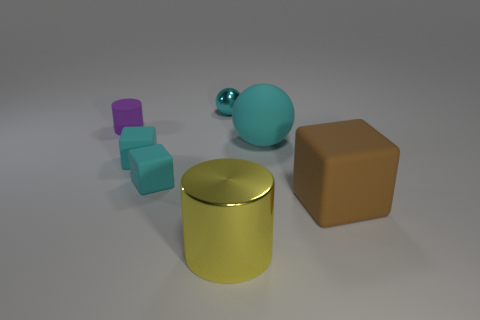There is a shiny object left of the yellow cylinder; what number of matte things are in front of it?
Make the answer very short. 5. Are the cylinder that is behind the brown matte block and the thing that is right of the big cyan rubber ball made of the same material?
Your answer should be compact. Yes. What number of large cyan rubber things have the same shape as the cyan metal thing?
Provide a short and direct response. 1. What number of big objects are the same color as the small metal sphere?
Your answer should be very brief. 1. There is a thing to the right of the cyan matte ball; is its shape the same as the object that is behind the tiny matte cylinder?
Give a very brief answer. No. There is a sphere behind the cylinder behind the yellow cylinder; how many cyan rubber things are right of it?
Provide a succinct answer. 1. The sphere that is to the right of the small cyan object that is behind the cylinder that is behind the yellow metal thing is made of what material?
Your answer should be compact. Rubber. Is the cylinder that is to the left of the large metallic thing made of the same material as the brown thing?
Provide a short and direct response. Yes. What number of cyan balls are the same size as the purple cylinder?
Ensure brevity in your answer.  1. Are there more small cylinders in front of the big brown matte block than tiny purple cylinders that are to the right of the cyan shiny ball?
Provide a succinct answer. No. 